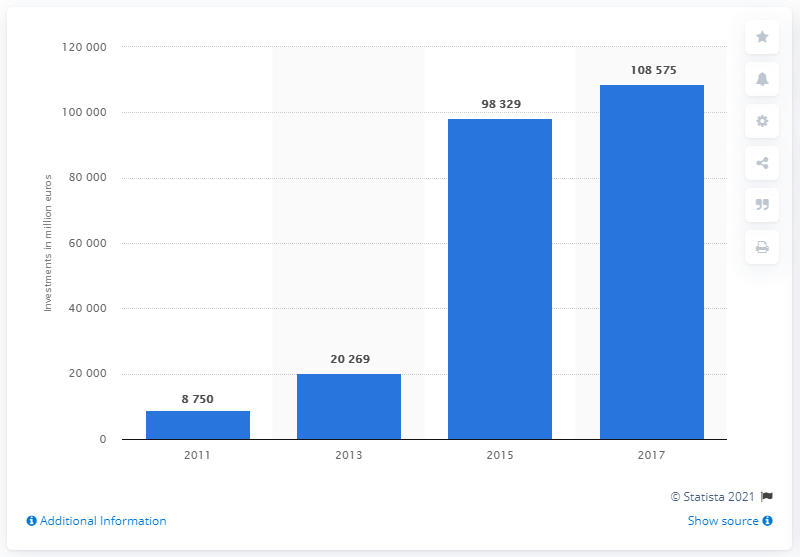Point out several critical features in this image. In 2011, the value of impact investing was approximately 8,750. 